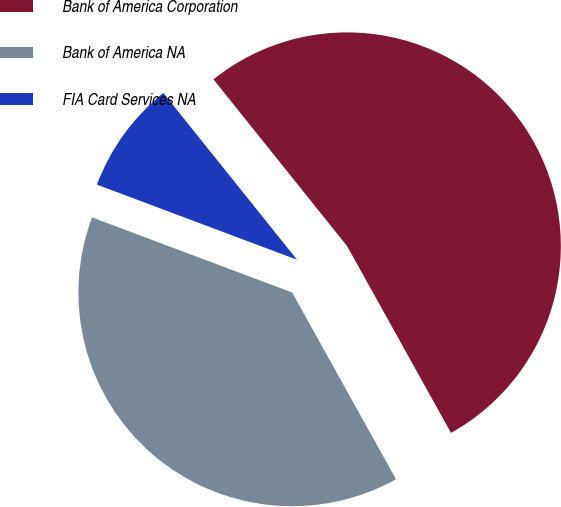<chart> <loc_0><loc_0><loc_500><loc_500><pie_chart><fcel>Bank of America Corporation<fcel>Bank of America NA<fcel>FIA Card Services NA<nl><fcel>52.67%<fcel>38.79%<fcel>8.53%<nl></chart> 